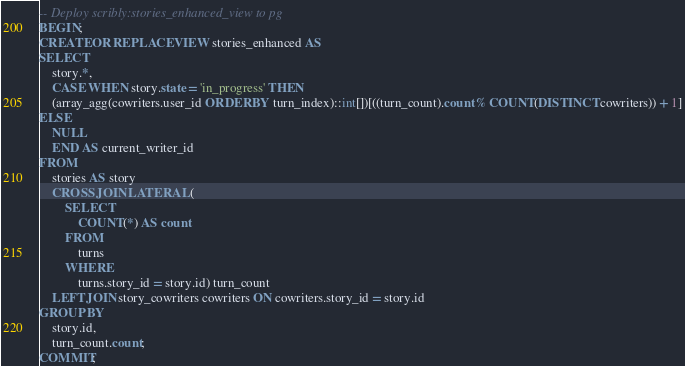Convert code to text. <code><loc_0><loc_0><loc_500><loc_500><_SQL_>-- Deploy scribly:stories_enhanced_view to pg
BEGIN;
CREATE OR REPLACE VIEW stories_enhanced AS
SELECT
    story.*,
    CASE WHEN story.state = 'in_progress' THEN
    (array_agg(cowriters.user_id ORDER BY turn_index)::int[])[((turn_count).count % COUNT(DISTINCT cowriters)) + 1]
ELSE
    NULL
    END AS current_writer_id
FROM
    stories AS story
    CROSS JOIN LATERAL (
        SELECT
            COUNT(*) AS count
        FROM
            turns
        WHERE
            turns.story_id = story.id) turn_count
    LEFT JOIN story_cowriters cowriters ON cowriters.story_id = story.id
GROUP BY
    story.id,
    turn_count.count;
COMMIT;

</code> 